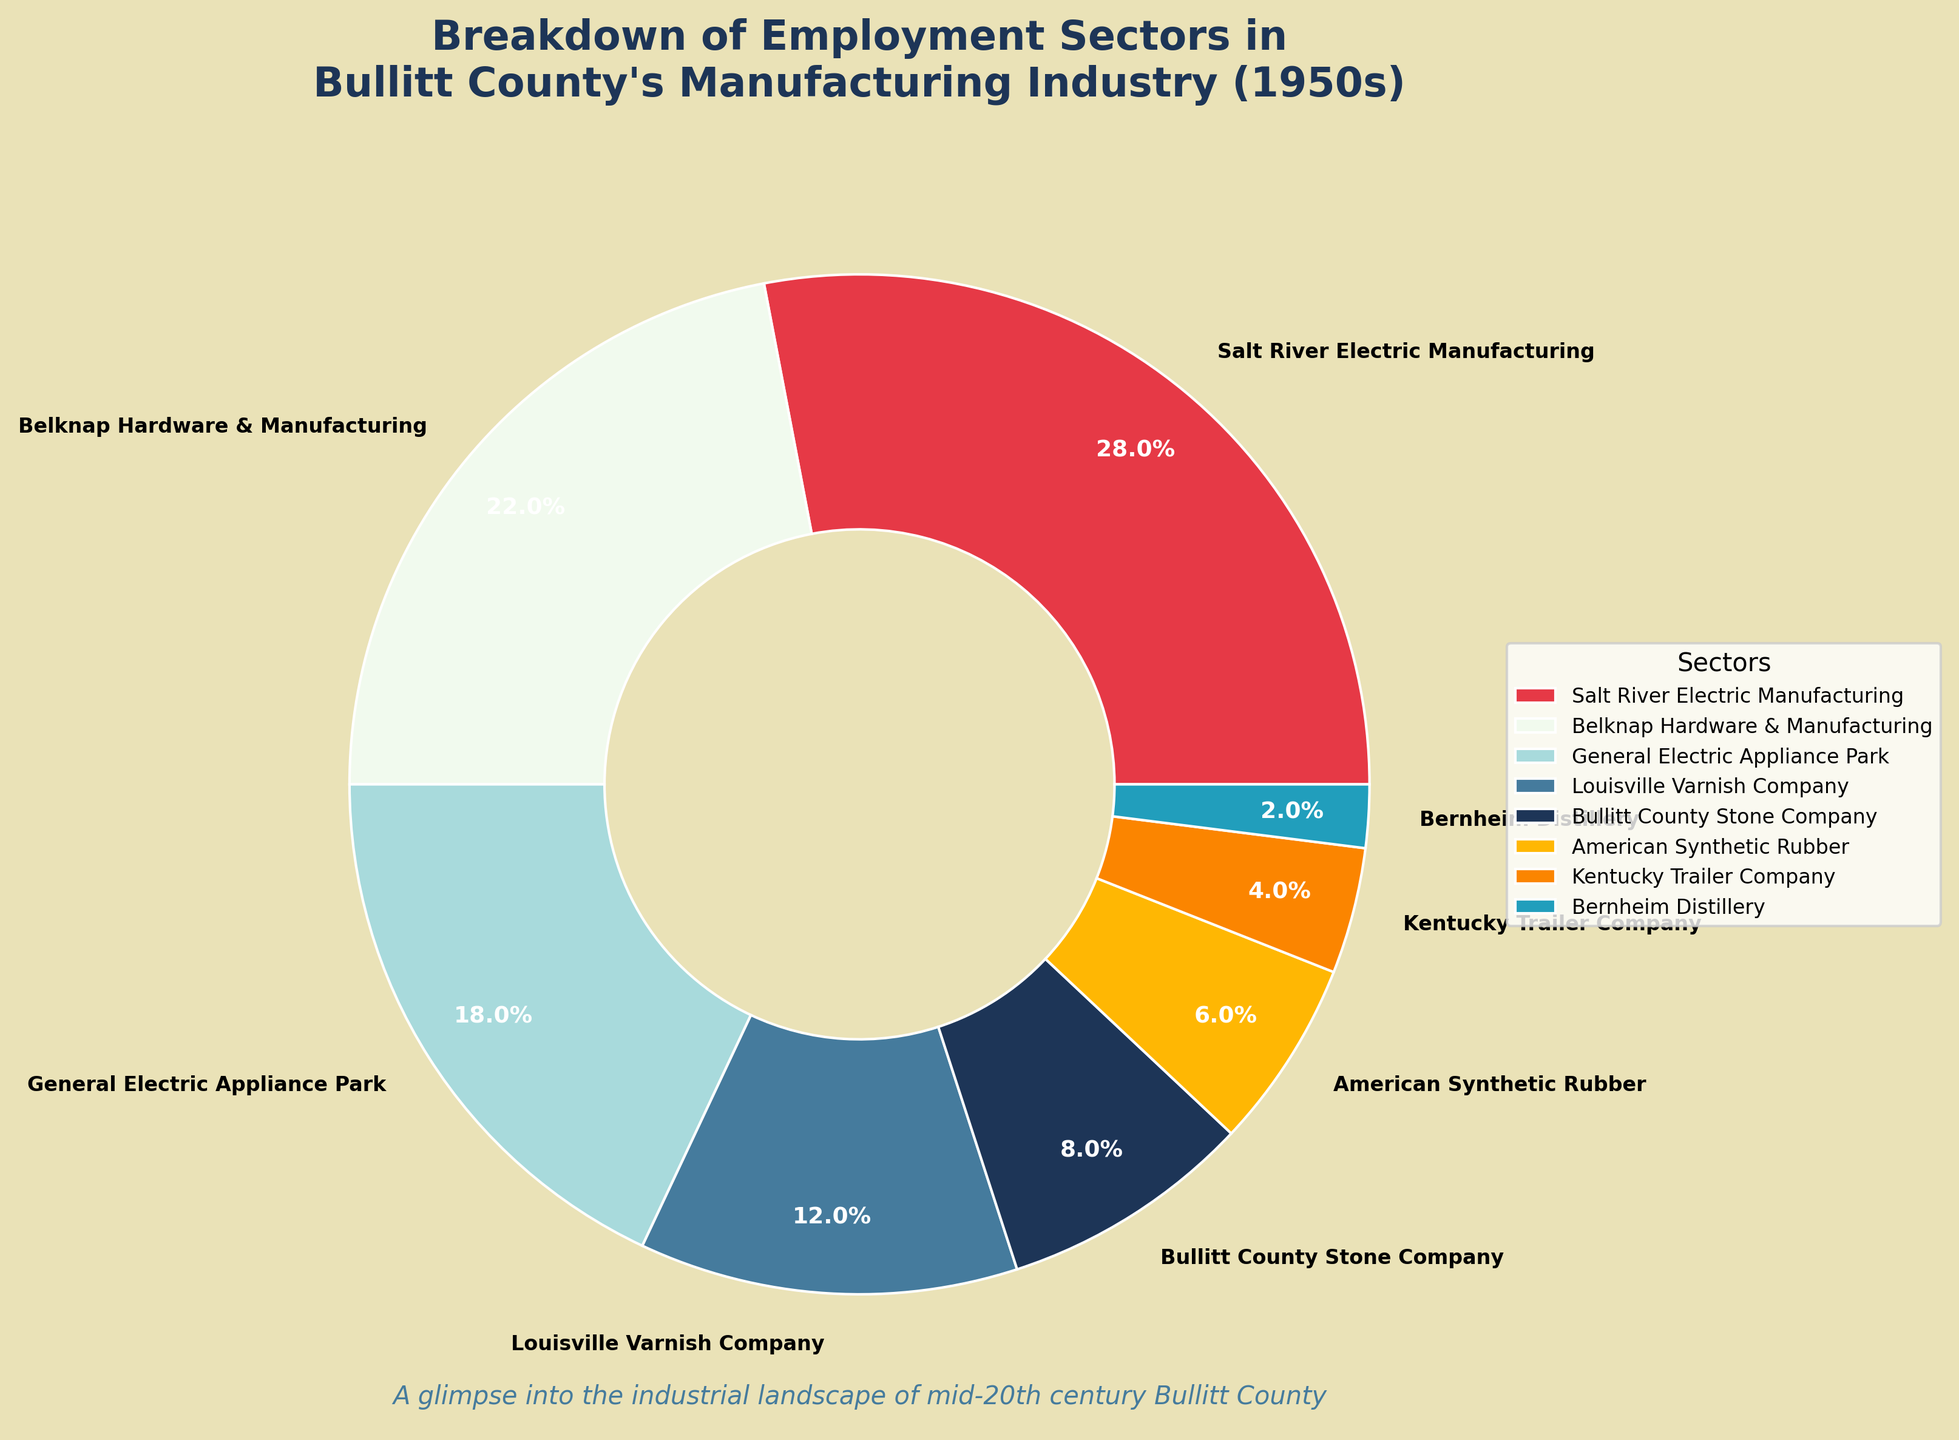What percentage of employment does Salt River Electric Manufacturing contribute in Bullitt County's manufacturing industry in the 1950s? Salt River Electric Manufacturing is indicated in the legend of the pie chart. The label shows it contributes 28%.
Answer: 28% Which company has a lower employment percentage: Kentucky Trailer Company or American Synthetic Rubber? Compare the percentages for Kentucky Trailer Company (4%) and American Synthetic Rubber (6%) in the pie chart. Kentucky Trailer Company has a lower percentage.
Answer: Kentucky Trailer Company What is the combined employment percentage of General Electric Appliance Park and Louisville Varnish Company? Add the percentages of General Electric Appliance Park (18%) and Louisville Varnish Company (12%). The combined percentage is 18% + 12% = 30%.
Answer: 30% Which company sector has the smallest share of employment, and what is its percentage? Bernheim Distillery has the smallest segment on the pie chart, labeled with 2%.
Answer: Bernheim Distillery, 2% How much greater is the employment contribution of Salt River Electric Manufacturing compared to Belknap Hardware & Manufacturing? Salt River Electric Manufacturing is at 28% and Belknap Hardware & Manufacturing at 22%. The difference is 28% - 22% = 6%.
Answer: 6% Which sector uses the color blue? The sector with blue shading in the pie chart corresponds to General Electric Appliance Park.
Answer: General Electric Appliance Park What's the total employment percentage of companies contributing less than 10% each? The sectors contributing less than 10% each are Bullitt County Stone Company (8%), American Synthetic Rubber (6%), Kentucky Trailer Company (4%), and Bernheim Distillery (2%). Sum these percentages: 8% + 6% + 4% + 2% = 20%.
Answer: 20% Are there more sectors contributing above or below 10% to the employment in Bullitt County? Sectors contributing above 10%: Salt River Electric Manufacturing, Belknap Hardware & Manufacturing, General Electric Appliance Park, Louisville Varnish Company (4 sectors). Sectors contributing below 10%: Bullitt County Stone Company, American Synthetic Rubber, Kentucky Trailer Company, Bernheim Distillery (4 sectors). Both are equal.
Answer: Equal Which sector contributes the third-highest percentage to employment in Bullitt County's manufacturing industry? The third-highest percentage is found by listing the sectors in descending order: 28% (Salt River Electric Manufacturing), 22% (Belknap Hardware & Manufacturing), 18% (General Electric Appliance Park). The third one is General Electric Appliance Park at 18%.
Answer: General Electric Appliance Park 